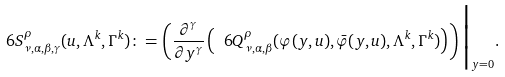<formula> <loc_0><loc_0><loc_500><loc_500>\ 6 S ^ { \rho } _ { \nu , \alpha , \beta , \gamma } ( u , \Lambda ^ { k } , \Gamma ^ { k } ) \colon = \left ( \frac { \partial ^ { \gamma } } { \partial y ^ { \gamma } } \left ( \ 6 Q ^ { \rho } _ { \nu , \alpha , \beta } ( \varphi ( y , u ) , \bar { \varphi } ( y , u ) , \Lambda ^ { k } , \Gamma ^ { k } ) \right ) \right ) \Big | _ { y = 0 } .</formula> 